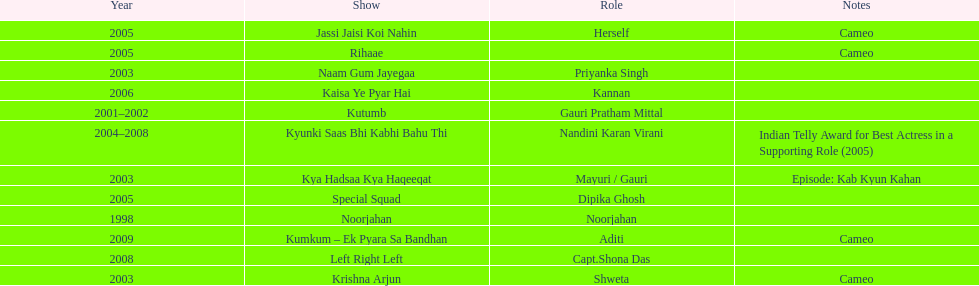The show above left right left Kaisa Ye Pyar Hai. 